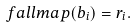Convert formula to latex. <formula><loc_0><loc_0><loc_500><loc_500>\ f a l l m a p ( b _ { i } ) = r _ { i } .</formula> 